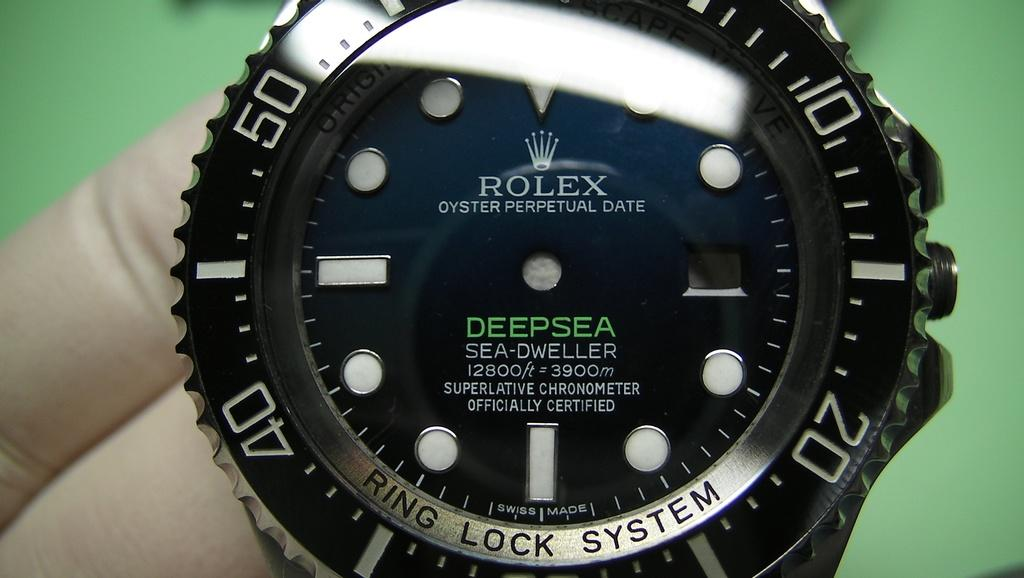<image>
Create a compact narrative representing the image presented. Face of a watch which says DEEPSEA in green. 